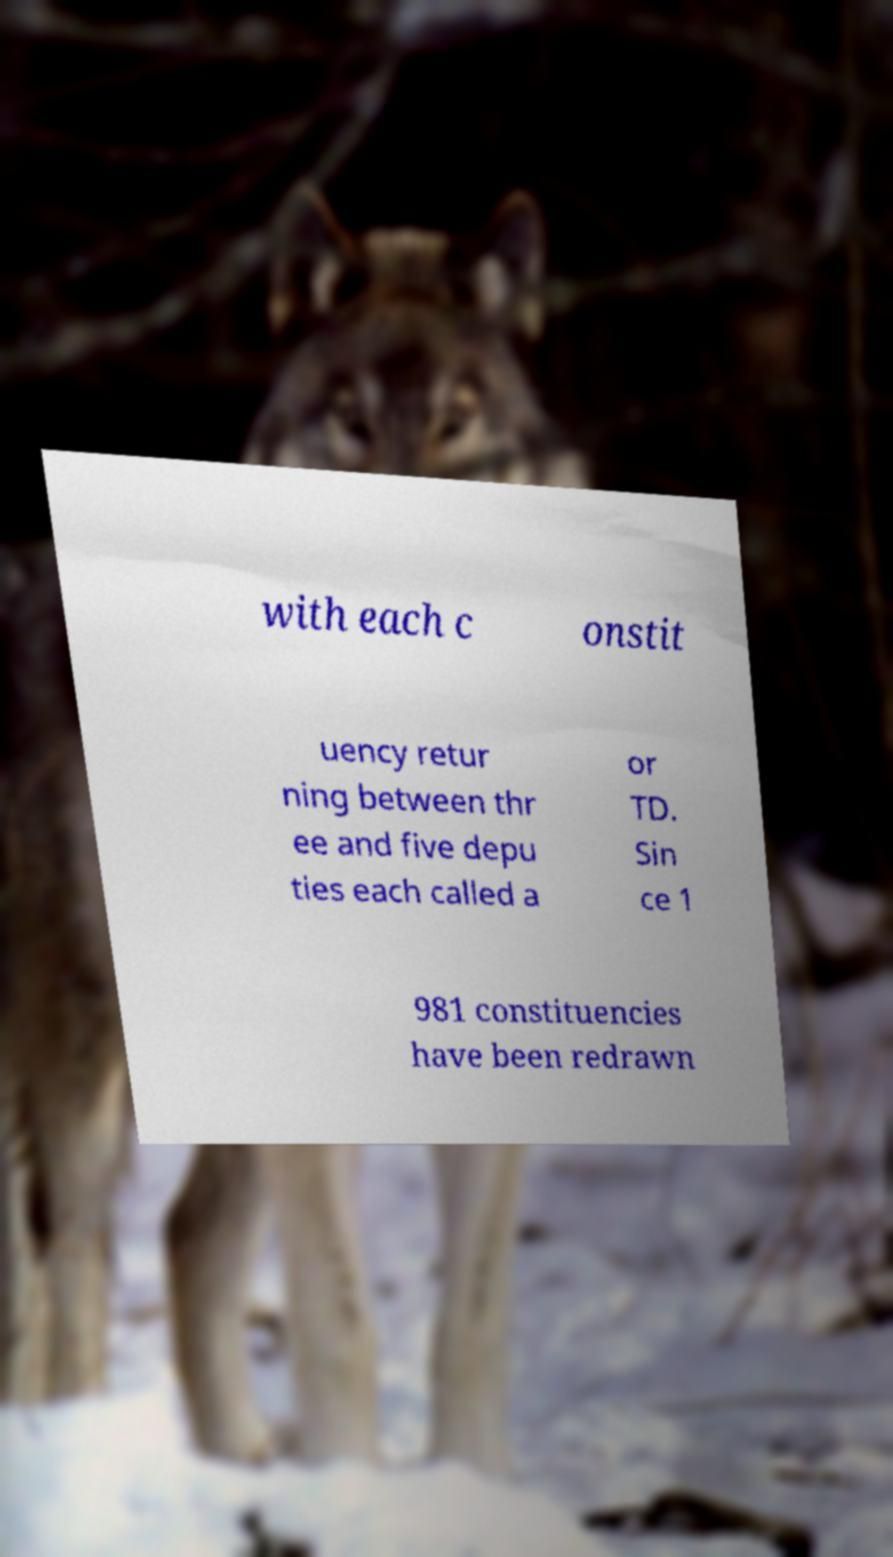There's text embedded in this image that I need extracted. Can you transcribe it verbatim? with each c onstit uency retur ning between thr ee and five depu ties each called a or TD. Sin ce 1 981 constituencies have been redrawn 